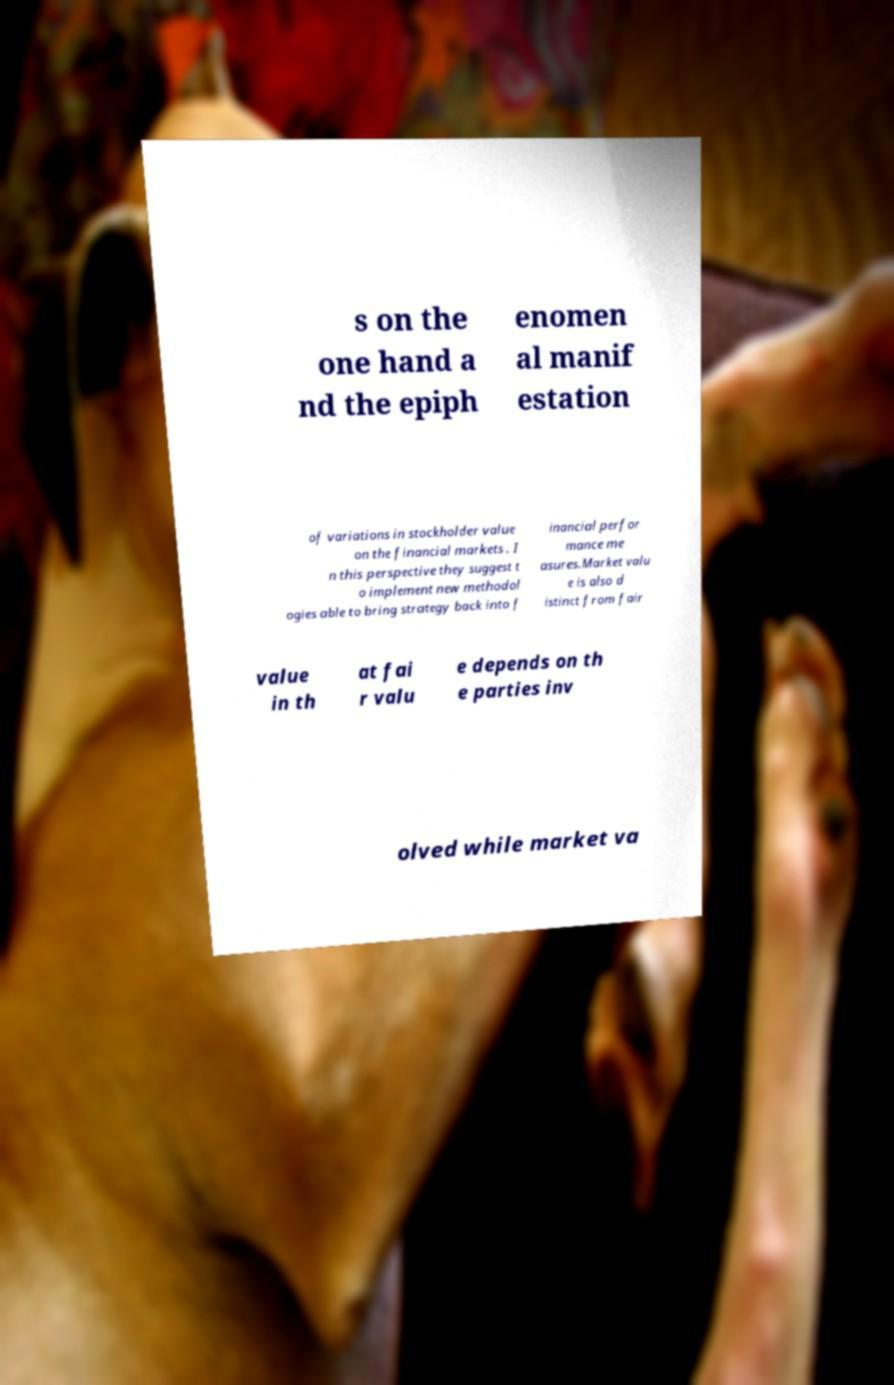Please read and relay the text visible in this image. What does it say? s on the one hand a nd the epiph enomen al manif estation of variations in stockholder value on the financial markets . I n this perspective they suggest t o implement new methodol ogies able to bring strategy back into f inancial perfor mance me asures.Market valu e is also d istinct from fair value in th at fai r valu e depends on th e parties inv olved while market va 